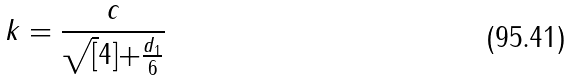<formula> <loc_0><loc_0><loc_500><loc_500>k = \frac { c } { \sqrt { [ } 4 ] { + \frac { d _ { 1 } } { 6 } } }</formula> 